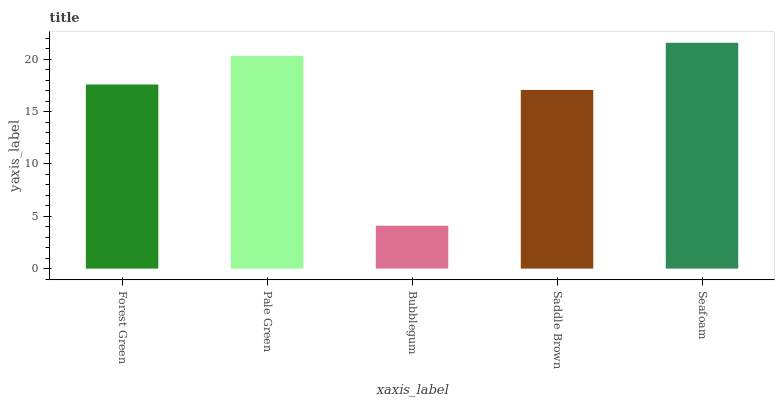Is Pale Green the minimum?
Answer yes or no. No. Is Pale Green the maximum?
Answer yes or no. No. Is Pale Green greater than Forest Green?
Answer yes or no. Yes. Is Forest Green less than Pale Green?
Answer yes or no. Yes. Is Forest Green greater than Pale Green?
Answer yes or no. No. Is Pale Green less than Forest Green?
Answer yes or no. No. Is Forest Green the high median?
Answer yes or no. Yes. Is Forest Green the low median?
Answer yes or no. Yes. Is Bubblegum the high median?
Answer yes or no. No. Is Seafoam the low median?
Answer yes or no. No. 